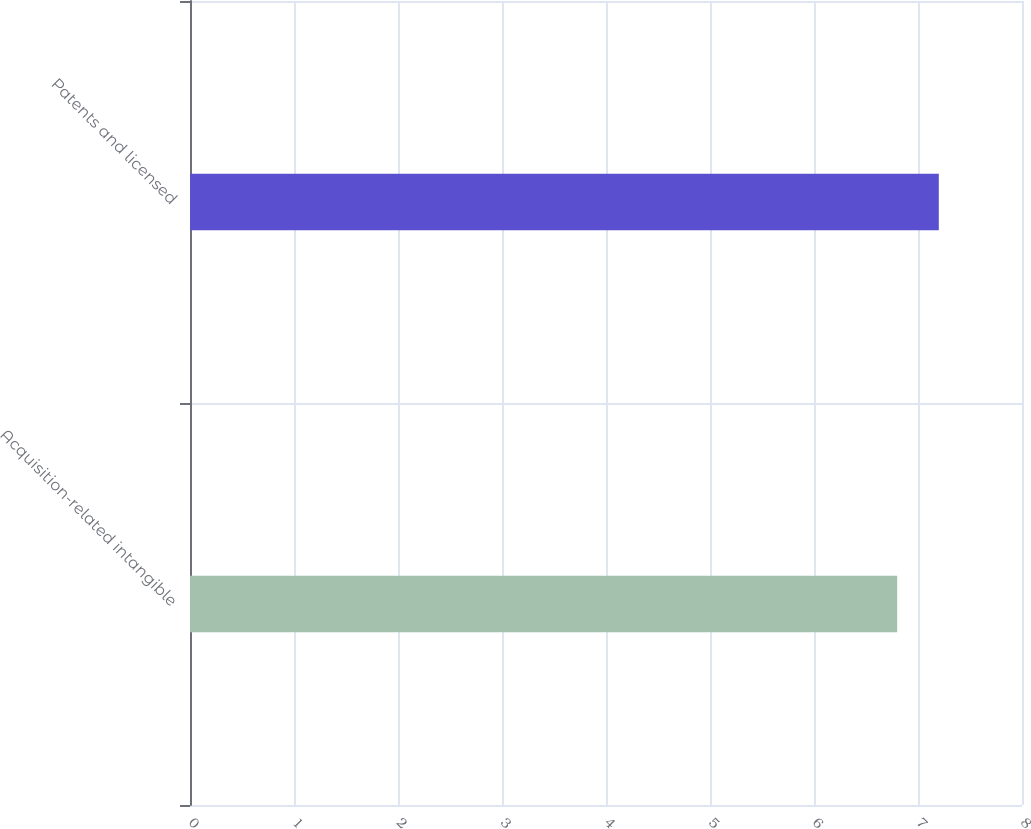Convert chart. <chart><loc_0><loc_0><loc_500><loc_500><bar_chart><fcel>Acquisition-related intangible<fcel>Patents and licensed<nl><fcel>6.8<fcel>7.2<nl></chart> 